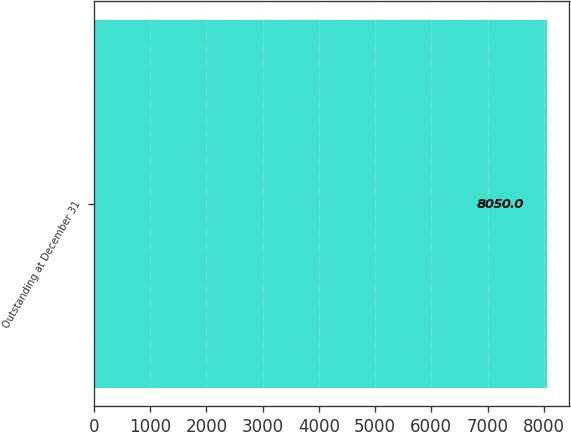Convert chart to OTSL. <chart><loc_0><loc_0><loc_500><loc_500><bar_chart><fcel>Outstanding at December 31<nl><fcel>8050<nl></chart> 